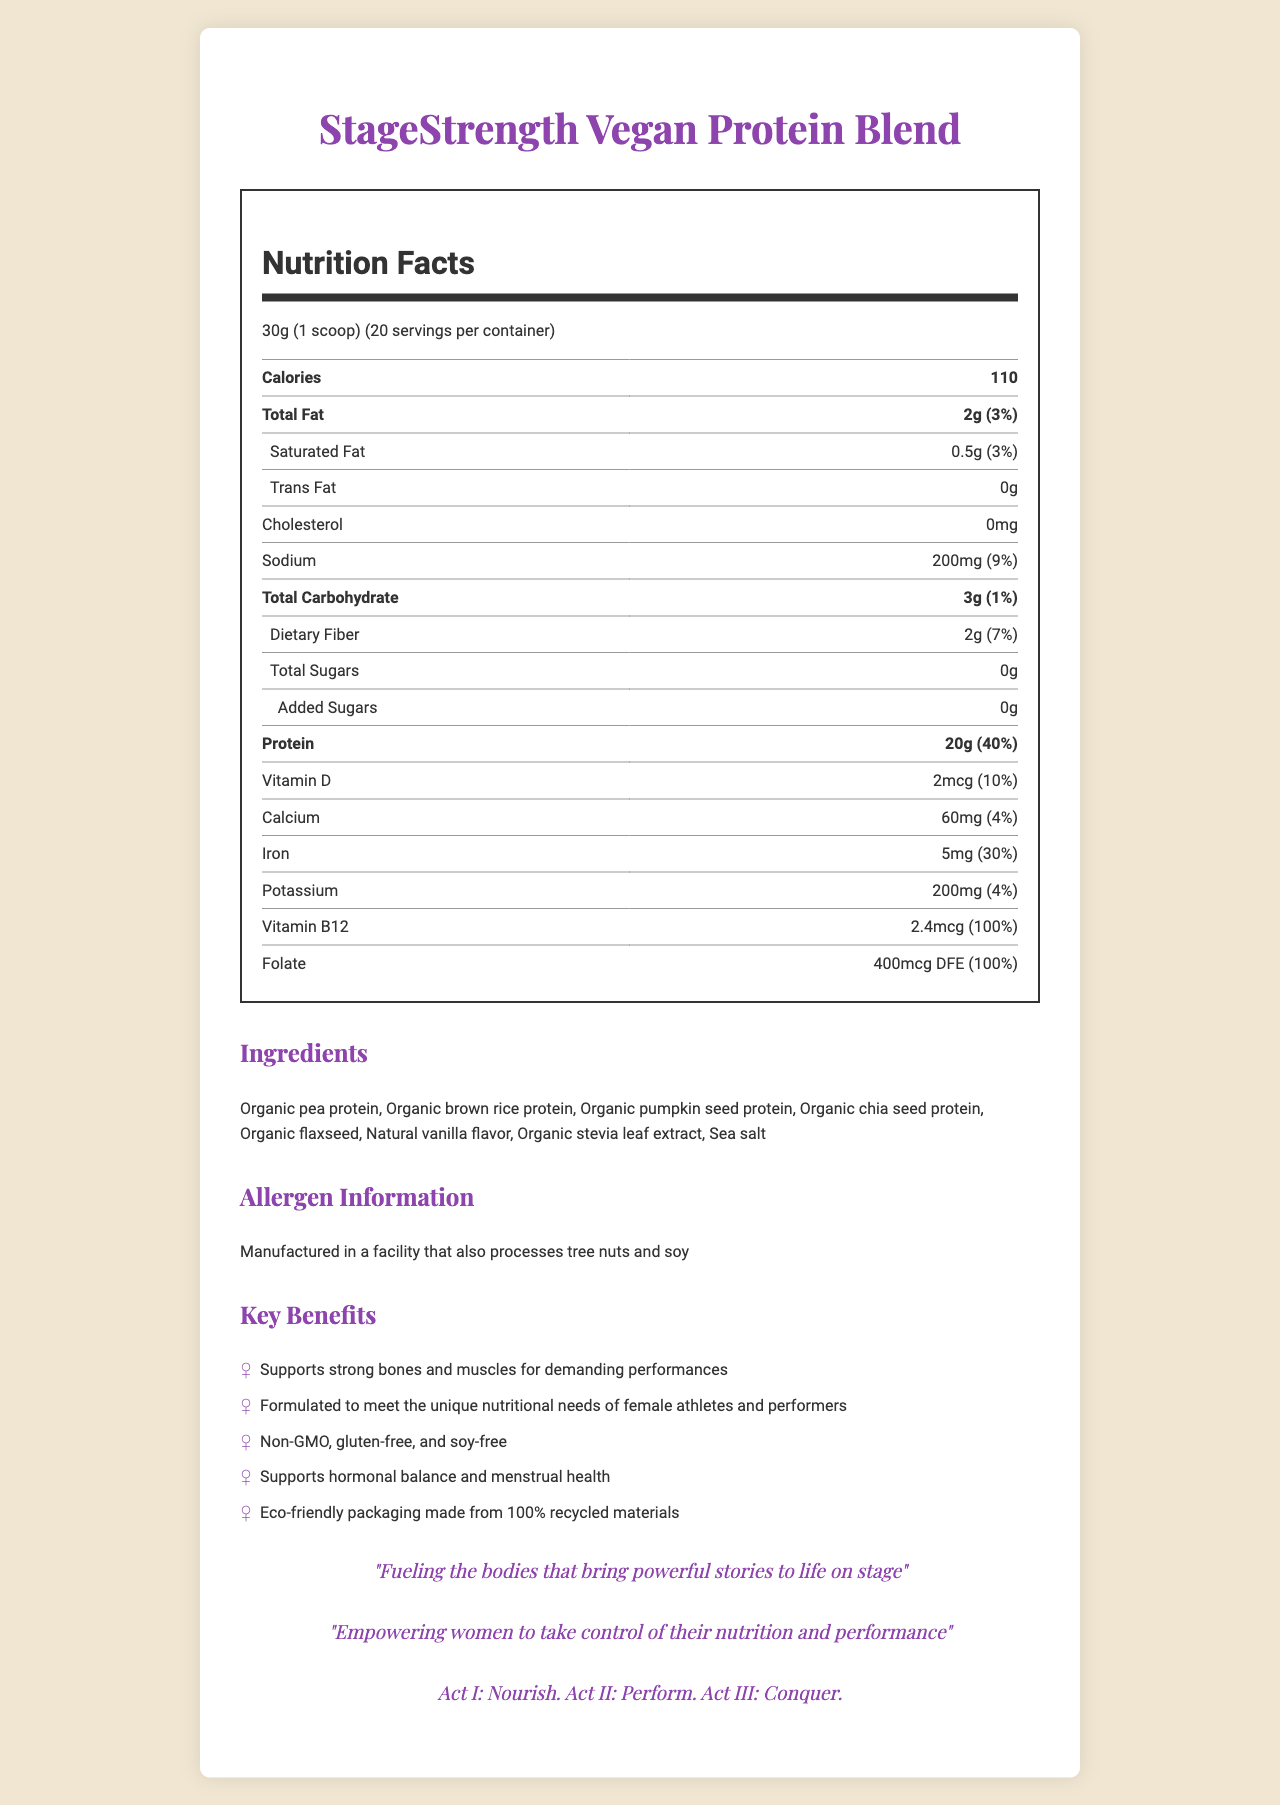how many calories are in one serving? The document lists the calories per serving as 110.
Answer: 110 calories what is the serving size of StageStrength Vegan Protein Blend? The serving size is specified as 30g (1 scoop).
Answer: 30g (1 scoop) how much protein is in each serving? The document states that each serving contains 20g of protein.
Answer: 20g what are the primary ingredients in the protein blend? The ingredients are listed in the document.
Answer: Organic pea protein, Organic brown rice protein, Organic pumpkin seed protein, Organic chia seed protein, Organic flaxseed, Natural vanilla flavor, Organic stevia leaf extract, Sea salt what percentage of the daily value of protein does one serving provide? The document states that the daily value percentage for protein is 40%.
Answer: 40% which of the following is a marketing claim of the product? A. Contains animal-based proteins B. Non-GMO C. Artificial flavors included D. Sugar-added The marketing claims listed include "Non-GMO."
Answer: B. Non-GMO how much dietary fiber is there per serving and what percentage of the daily value does it represent? The document lists the dietary fiber content as 2g, which is 7% of the daily value.
Answer: 2g, 7% are there any sugars added to this protein blend? (Yes/No) The document specifies that there are 0g of total sugars and 0g of added sugars.
Answer: No which nutrient provides the highest daily value percentage? A. Vitamin D B. Iron C. Vitamin B12 D. Folate Vitamin B12 provides 100% of the daily value, which is the highest among the listed nutrients.
Answer: C. Vitamin B12 describe the allergen information for this product. The allergen information specifies that the product is manufactured in a facility that handles tree nuts and soy.
Answer: Manufactured in a facility that also processes tree nuts and soy what is the amount of sodium per serving and its daily value percentage? The document lists sodium as 200mg per serving and states that this represents 9% of the daily value.
Answer: 200mg, 9% how many servings are there per container? The document states that there are 20 servings per container.
Answer: 20 what are the main health benefits promoted by this product? The marketing claims include these benefits.
Answer: Supports strong bones and muscles, tailored for female athletes and performers, supports hormonal balance and menstrual health, eco-friendly packaging. which theatrical theme is referenced in the quotes? The document includes the theatrical reference "Act I: Nourish. Act II: Perform. Act III: Conquer."
Answer: Act I: Nourish. Act II: Perform. Act III: Conquer. summarize the key information presented in the document. The summary covers the main aspects, including nutritional facts, ingredients, allergen info, marketing claims, and thematic elements.
Answer: The document provides nutritional information for StageStrength Vegan Protein Blend, highlighting it as a plant-based protein powder designed for female athletes and performers. It details the serving size, calories, and daily values for various nutrients, listing key ingredients and allergen information. Marketing claims emphasize the blend's support for strength, performance, hormonal balance, and menstrual health, along with eco-friendly packaging. The document also features feminist and theatrical themes. what other products does the manufacturer of StageStrength Vegan Protein Blend produce? The document does not provide information about other products produced by the manufacturer.
Answer: Cannot be determined 